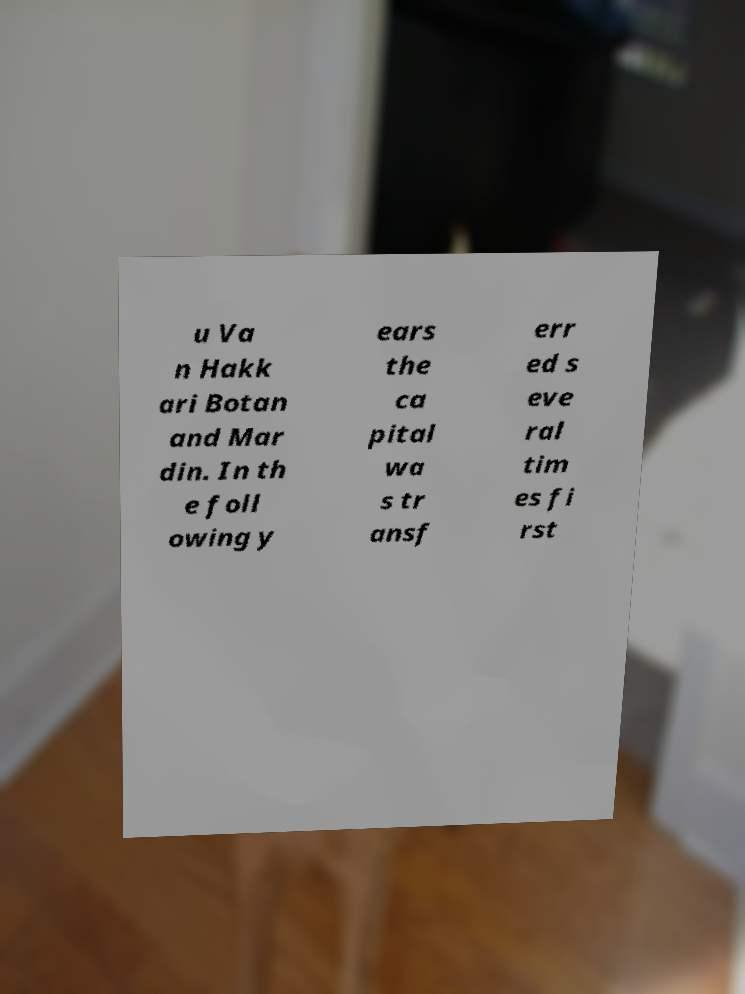Could you assist in decoding the text presented in this image and type it out clearly? u Va n Hakk ari Botan and Mar din. In th e foll owing y ears the ca pital wa s tr ansf err ed s eve ral tim es fi rst 